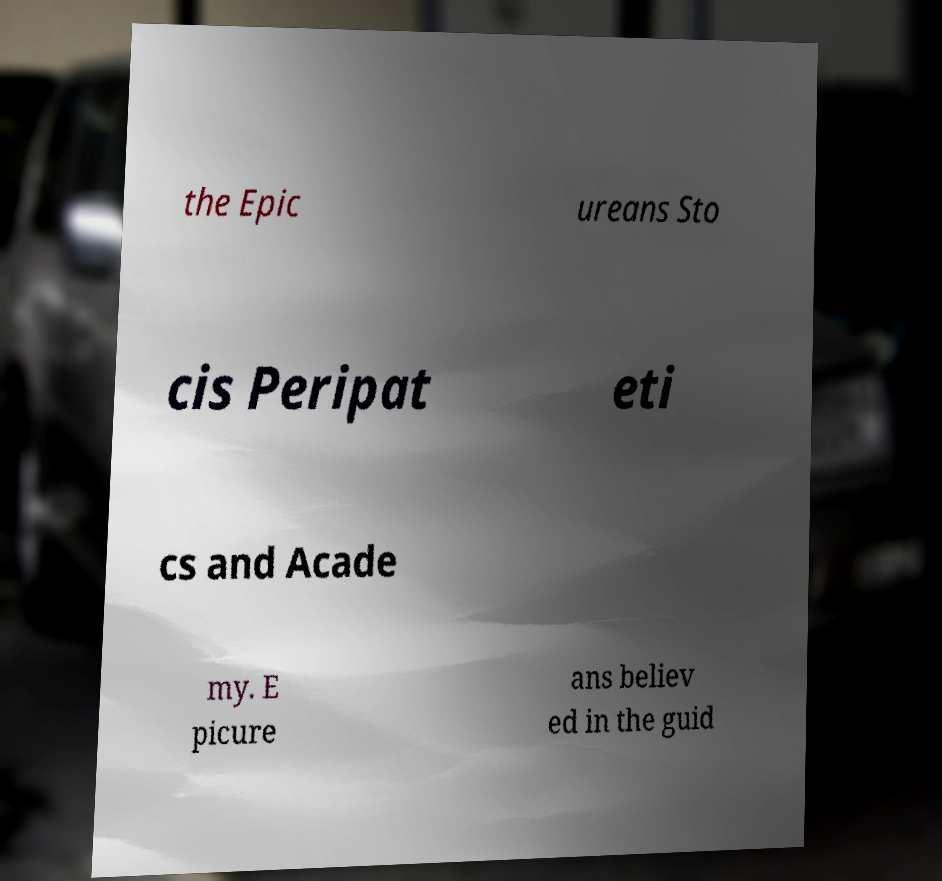What messages or text are displayed in this image? I need them in a readable, typed format. the Epic ureans Sto cis Peripat eti cs and Acade my. E picure ans believ ed in the guid 